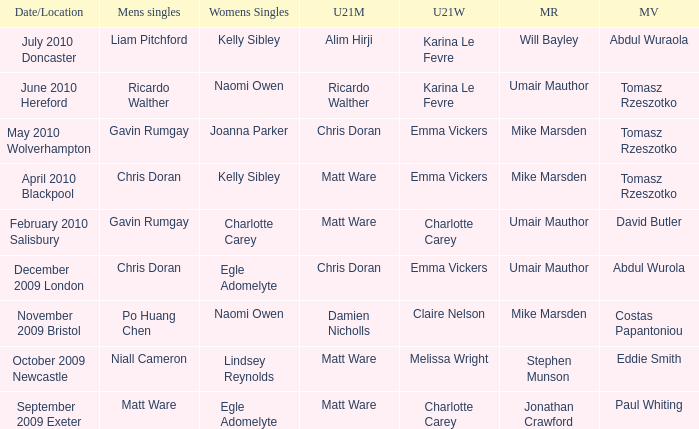When Matt Ware won the mens singles, who won the mixed restricted? Jonathan Crawford. 